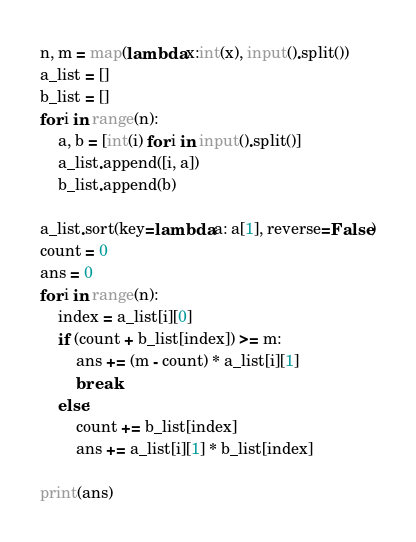<code> <loc_0><loc_0><loc_500><loc_500><_Python_>n, m = map(lambda x:int(x), input().split())
a_list = []
b_list = []
for i in range(n):
    a, b = [int(i) for i in input().split()]
    a_list.append([i, a])
    b_list.append(b)

a_list.sort(key=lambda a: a[1], reverse=False)
count = 0
ans = 0
for i in range(n):
    index = a_list[i][0]
    if (count + b_list[index]) >= m:
        ans += (m - count) * a_list[i][1]
        break
    else:
        count += b_list[index]
        ans += a_list[i][1] * b_list[index]

print(ans)

</code> 